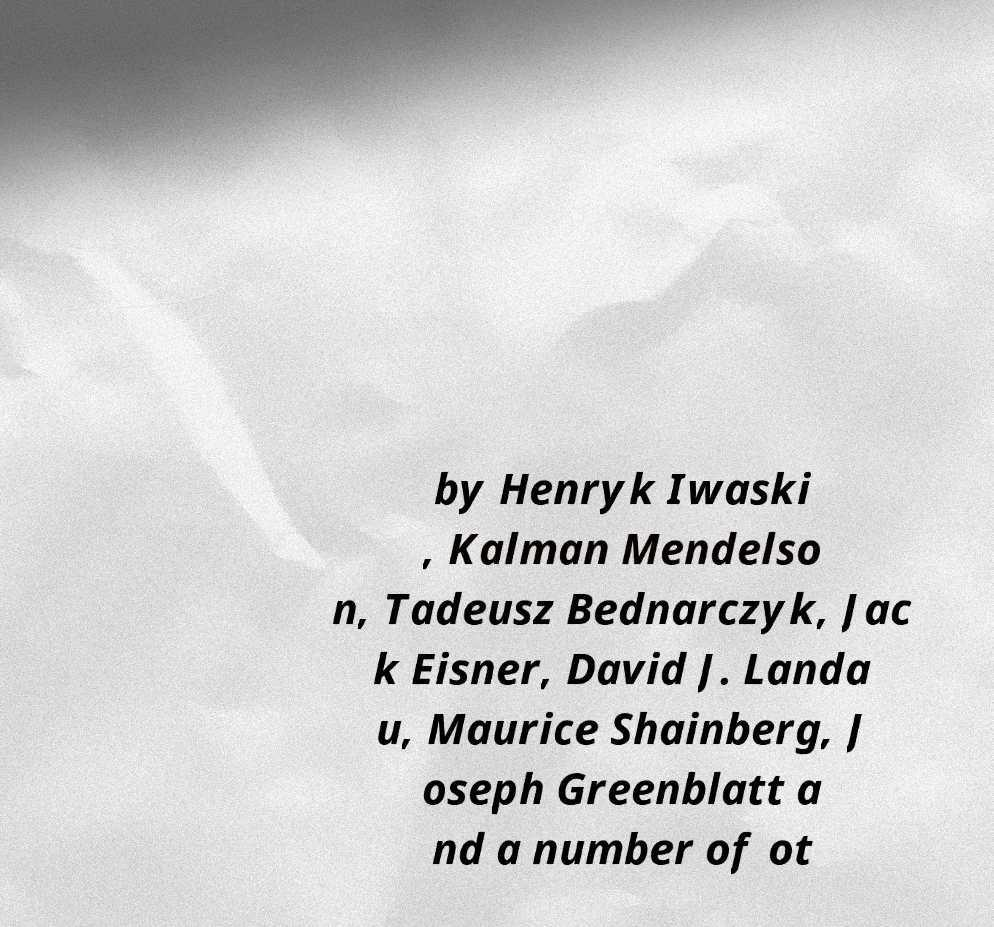Could you extract and type out the text from this image? by Henryk Iwaski , Kalman Mendelso n, Tadeusz Bednarczyk, Jac k Eisner, David J. Landa u, Maurice Shainberg, J oseph Greenblatt a nd a number of ot 